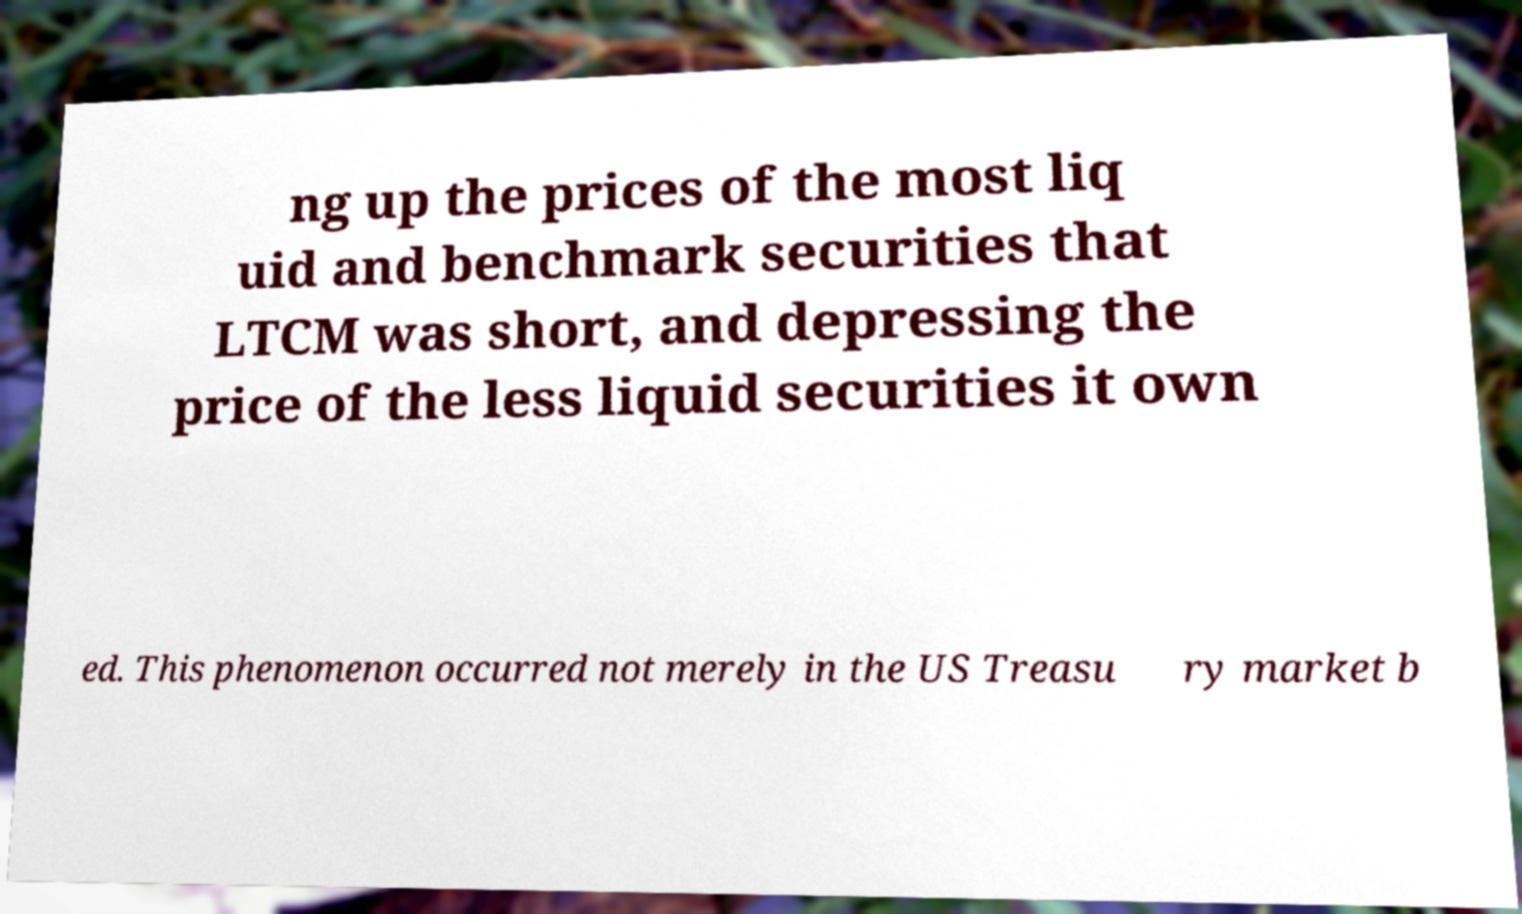For documentation purposes, I need the text within this image transcribed. Could you provide that? ng up the prices of the most liq uid and benchmark securities that LTCM was short, and depressing the price of the less liquid securities it own ed. This phenomenon occurred not merely in the US Treasu ry market b 